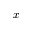Convert formula to latex. <formula><loc_0><loc_0><loc_500><loc_500>x</formula> 